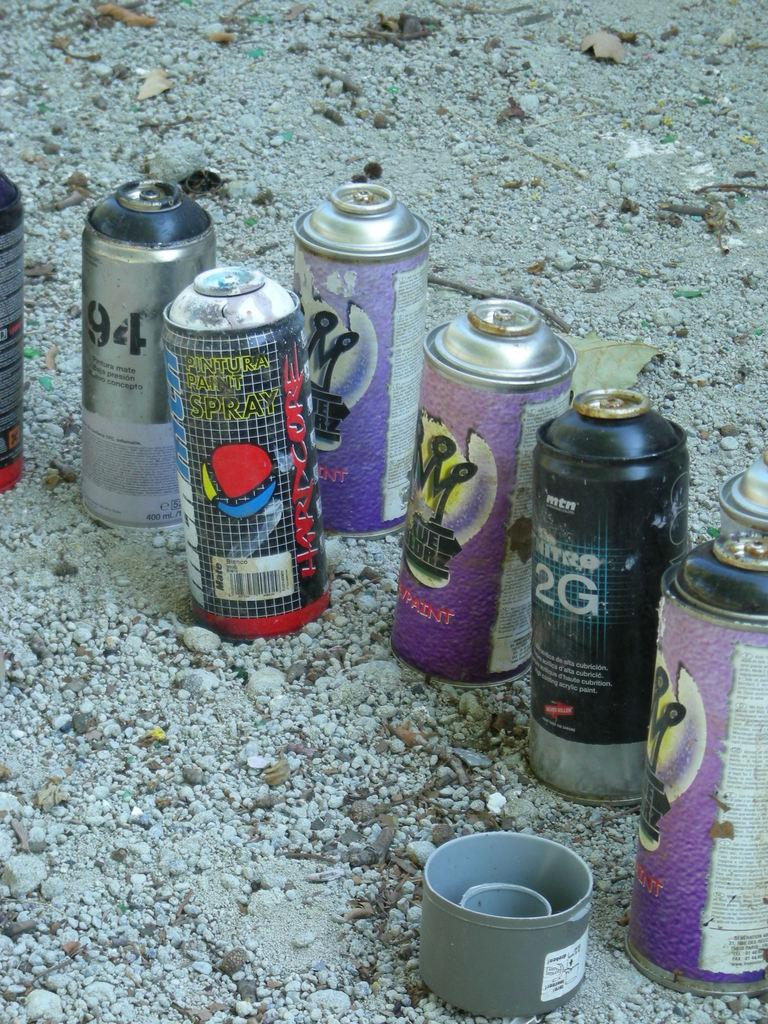<image>
Offer a succinct explanation of the picture presented. A can of spray paint that says 2G sits near several other cans on gravel. 